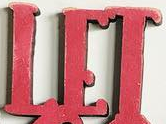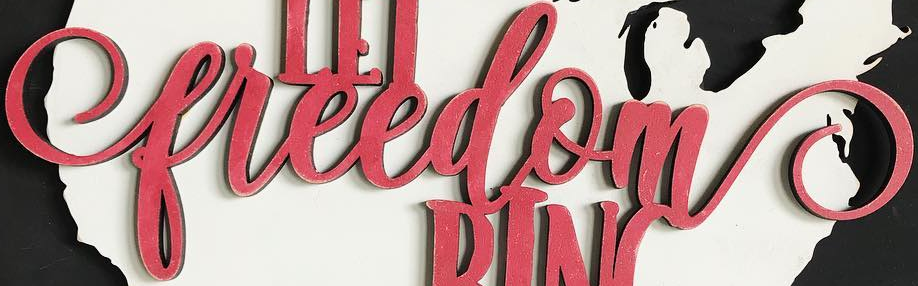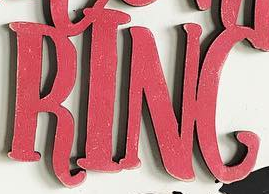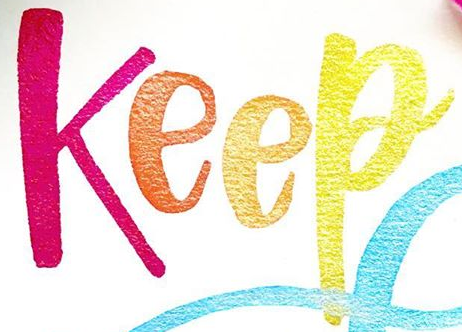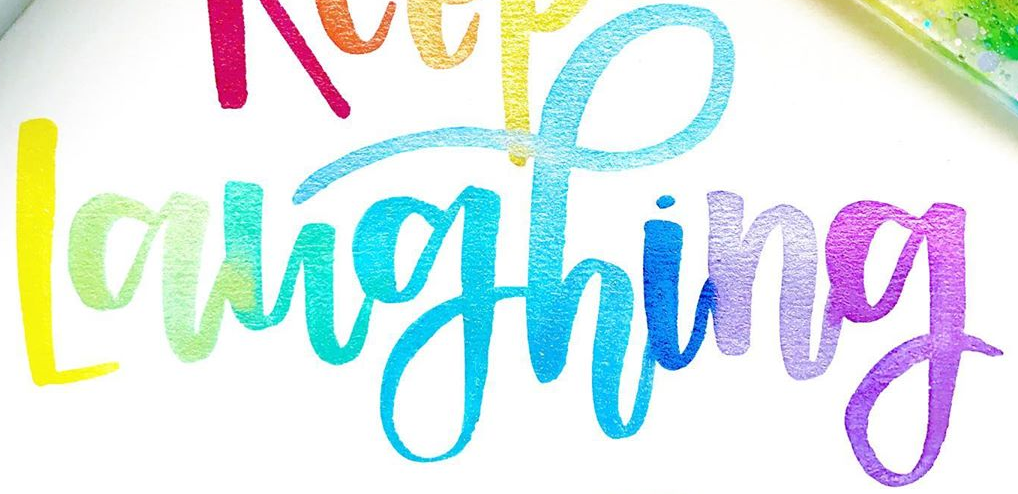What text appears in these images from left to right, separated by a semicolon? LET; freedom; RING; Keep; Laughing 